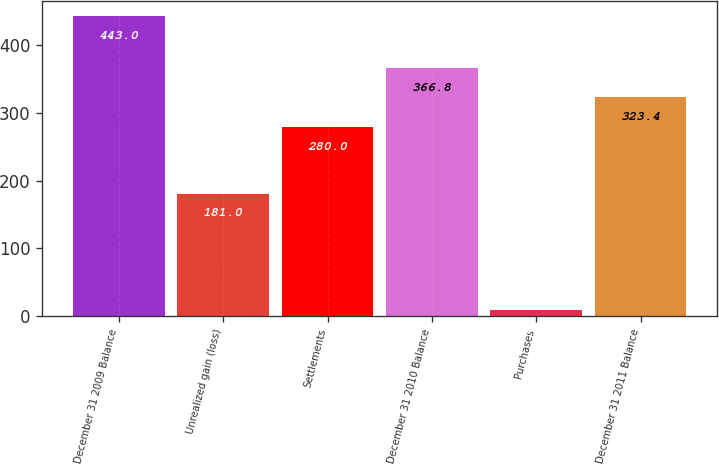Convert chart to OTSL. <chart><loc_0><loc_0><loc_500><loc_500><bar_chart><fcel>December 31 2009 Balance<fcel>Unrealized gain (loss)<fcel>Settlements<fcel>December 31 2010 Balance<fcel>Purchases<fcel>December 31 2011 Balance<nl><fcel>443<fcel>181<fcel>280<fcel>366.8<fcel>9<fcel>323.4<nl></chart> 